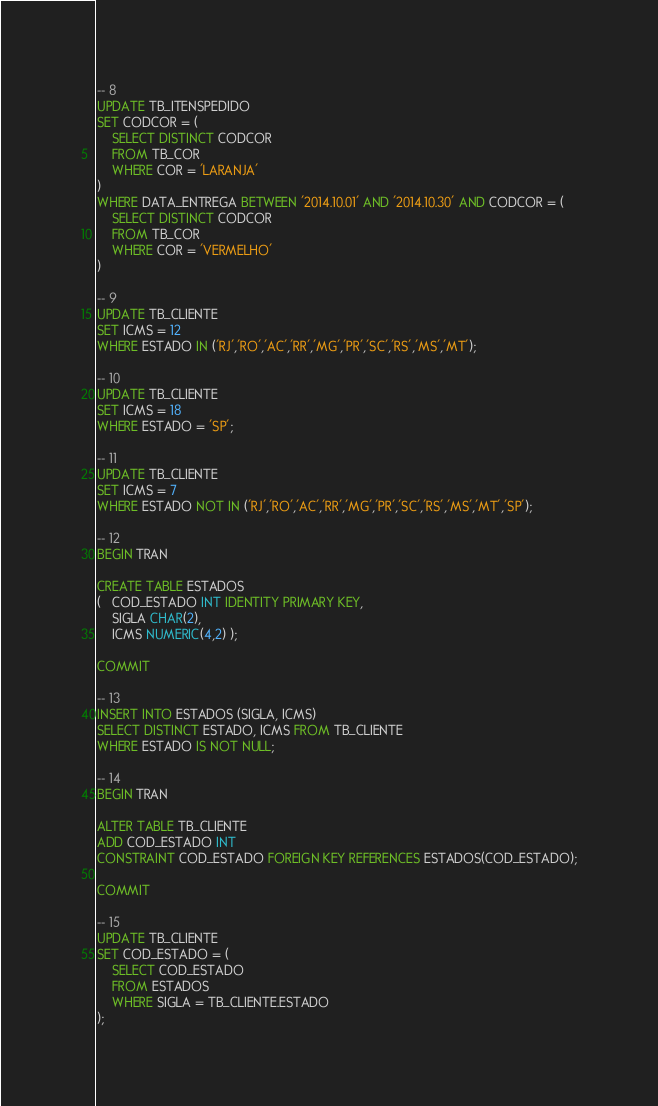<code> <loc_0><loc_0><loc_500><loc_500><_SQL_>-- 8 
UPDATE TB_ITENSPEDIDO
SET CODCOR = (
	SELECT DISTINCT CODCOR
	FROM TB_COR
	WHERE COR = 'LARANJA'
)
WHERE DATA_ENTREGA BETWEEN '2014.10.01' AND '2014.10.30' AND CODCOR = (
	SELECT DISTINCT CODCOR
	FROM TB_COR
	WHERE COR = 'VERMELHO'
)

-- 9
UPDATE TB_CLIENTE
SET ICMS = 12
WHERE ESTADO IN ('RJ','RO','AC','RR','MG','PR','SC','RS','MS','MT');

-- 10
UPDATE TB_CLIENTE
SET ICMS = 18
WHERE ESTADO = 'SP';

-- 11 
UPDATE TB_CLIENTE
SET ICMS = 7
WHERE ESTADO NOT IN ('RJ','RO','AC','RR','MG','PR','SC','RS','MS','MT','SP');

-- 12
BEGIN TRAN

CREATE TABLE ESTADOS
(   COD_ESTADO INT IDENTITY PRIMARY KEY,
	SIGLA CHAR(2),
	ICMS NUMERIC(4,2) );

COMMIT

-- 13
INSERT INTO ESTADOS (SIGLA, ICMS) 
SELECT DISTINCT ESTADO, ICMS FROM TB_CLIENTE
WHERE ESTADO IS NOT NULL;

-- 14
BEGIN TRAN

ALTER TABLE TB_CLIENTE
ADD COD_ESTADO INT 
CONSTRAINT COD_ESTADO FOREIGN KEY REFERENCES ESTADOS(COD_ESTADO);

COMMIT

-- 15
UPDATE TB_CLIENTE
SET COD_ESTADO = (
	SELECT COD_ESTADO 
	FROM ESTADOS
	WHERE SIGLA = TB_CLIENTE.ESTADO
);
</code> 